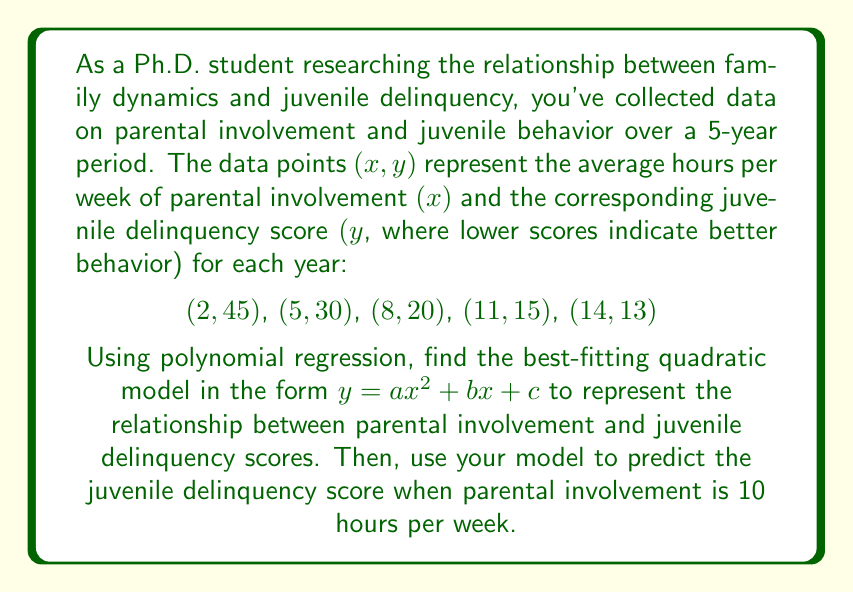Could you help me with this problem? To find the best-fitting quadratic model using polynomial regression, we need to solve a system of normal equations. For a quadratic model $y = ax^2 + bx + c$, we have three normal equations:

1) $\sum y = an\sum x^2 + b\sum x + nc$
2) $\sum xy = a\sum x^3 + b\sum x^2 + c\sum x$
3) $\sum x^2y = a\sum x^4 + b\sum x^3 + c\sum x^2$

Let's calculate the required sums:

$\sum x = 2 + 5 + 8 + 11 + 14 = 40$
$\sum y = 45 + 30 + 20 + 15 + 13 = 123$
$\sum x^2 = 4 + 25 + 64 + 121 + 196 = 410$
$\sum x^3 = 8 + 125 + 512 + 1331 + 2744 = 4720$
$\sum x^4 = 16 + 625 + 4096 + 14641 + 38416 = 57794$
$\sum xy = 90 + 150 + 160 + 165 + 182 = 747$
$\sum x^2y = 180 + 750 + 1280 + 1815 + 2548 = 6573$

Now, we can set up our system of equations:

1) $123 = 410a + 40b + 5c$
2) $747 = 4720a + 410b + 40c$
3) $6573 = 57794a + 4720b + 410c$

Solving this system of equations (you can use a calculator or computer algebra system for this step), we get:

$a \approx 0.2857$
$b \approx -8.7143$
$c \approx 61.4286$

Therefore, our quadratic model is:

$y = 0.2857x^2 - 8.7143x + 61.4286$

To predict the juvenile delinquency score when parental involvement is 10 hours per week, we substitute x = 10 into our model:

$y = 0.2857(10)^2 - 8.7143(10) + 61.4286$
$= 28.57 - 87.143 + 61.4286$
$= 2.8556$
Answer: The best-fitting quadratic model is $y = 0.2857x^2 - 8.7143x + 61.4286$. The predicted juvenile delinquency score when parental involvement is 10 hours per week is approximately 2.86. 